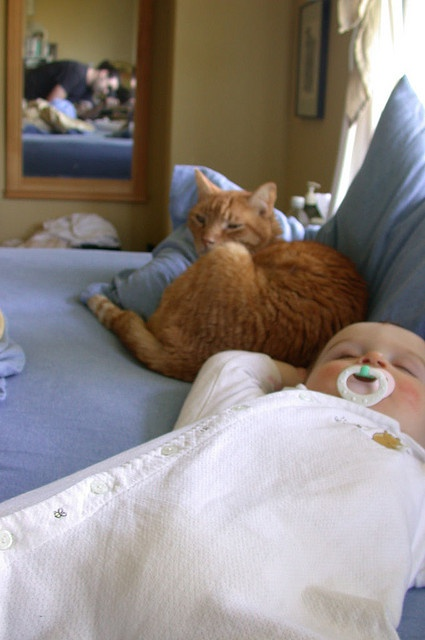Describe the objects in this image and their specific colors. I can see people in olive, lavender, darkgray, gray, and tan tones, bed in olive and gray tones, cat in olive, maroon, black, and gray tones, bed in olive, black, gray, and darkblue tones, and people in olive, black, gray, and darkgray tones in this image. 